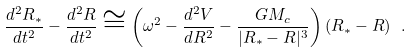<formula> <loc_0><loc_0><loc_500><loc_500>\frac { d ^ { 2 } R _ { * } } { d t ^ { 2 } } - \frac { d ^ { 2 } R } { d t ^ { 2 } } \cong \left ( \omega ^ { 2 } - \frac { d ^ { 2 } V } { d R ^ { 2 } } - \frac { G M _ { c } } { | R _ { * } - R | ^ { 3 } } \right ) ( R _ { * } - R ) \ .</formula> 